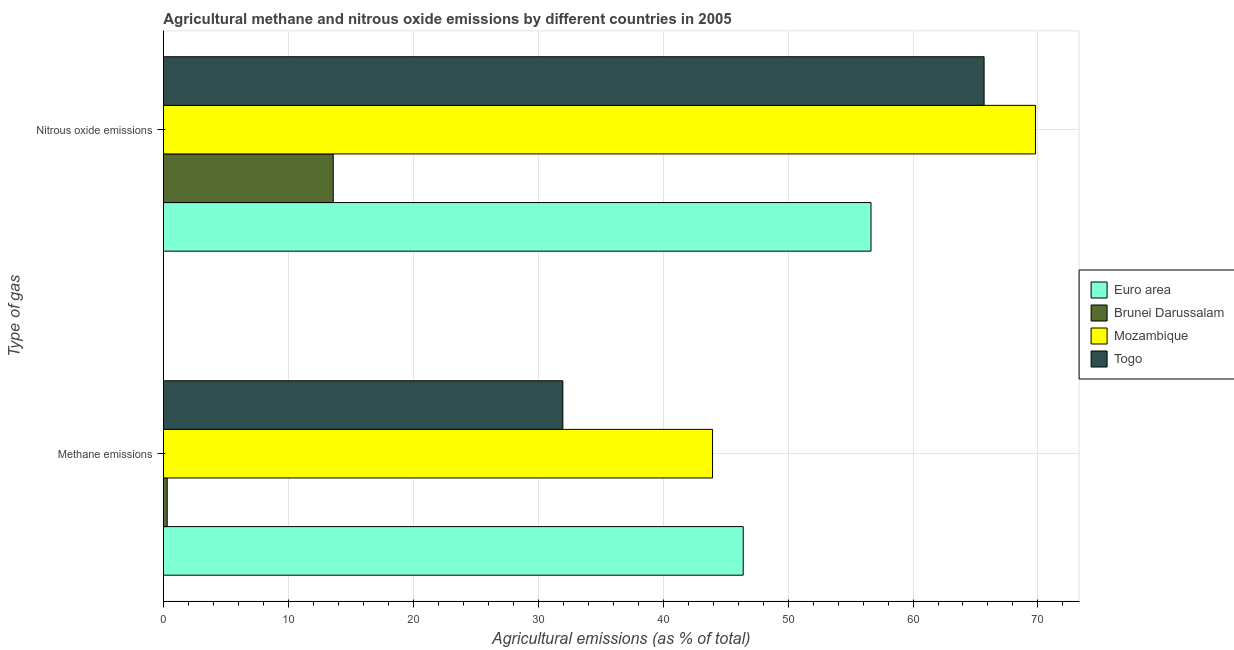How many different coloured bars are there?
Keep it short and to the point. 4. Are the number of bars per tick equal to the number of legend labels?
Give a very brief answer. Yes. Are the number of bars on each tick of the Y-axis equal?
Your answer should be very brief. Yes. How many bars are there on the 2nd tick from the top?
Your answer should be very brief. 4. How many bars are there on the 2nd tick from the bottom?
Ensure brevity in your answer.  4. What is the label of the 2nd group of bars from the top?
Your response must be concise. Methane emissions. What is the amount of nitrous oxide emissions in Euro area?
Offer a very short reply. 56.64. Across all countries, what is the maximum amount of methane emissions?
Provide a succinct answer. 46.41. Across all countries, what is the minimum amount of methane emissions?
Keep it short and to the point. 0.31. In which country was the amount of nitrous oxide emissions minimum?
Give a very brief answer. Brunei Darussalam. What is the total amount of methane emissions in the graph?
Give a very brief answer. 122.65. What is the difference between the amount of nitrous oxide emissions in Togo and that in Mozambique?
Ensure brevity in your answer.  -4.11. What is the difference between the amount of nitrous oxide emissions in Togo and the amount of methane emissions in Brunei Darussalam?
Your response must be concise. 65.38. What is the average amount of methane emissions per country?
Offer a very short reply. 30.66. What is the difference between the amount of methane emissions and amount of nitrous oxide emissions in Brunei Darussalam?
Give a very brief answer. -13.29. What is the ratio of the amount of nitrous oxide emissions in Mozambique to that in Togo?
Make the answer very short. 1.06. Is the amount of nitrous oxide emissions in Euro area less than that in Brunei Darussalam?
Give a very brief answer. No. Are all the bars in the graph horizontal?
Your answer should be compact. Yes. How many countries are there in the graph?
Keep it short and to the point. 4. What is the difference between two consecutive major ticks on the X-axis?
Your response must be concise. 10. How are the legend labels stacked?
Give a very brief answer. Vertical. What is the title of the graph?
Keep it short and to the point. Agricultural methane and nitrous oxide emissions by different countries in 2005. What is the label or title of the X-axis?
Offer a terse response. Agricultural emissions (as % of total). What is the label or title of the Y-axis?
Keep it short and to the point. Type of gas. What is the Agricultural emissions (as % of total) of Euro area in Methane emissions?
Your answer should be very brief. 46.41. What is the Agricultural emissions (as % of total) in Brunei Darussalam in Methane emissions?
Offer a terse response. 0.31. What is the Agricultural emissions (as % of total) in Mozambique in Methane emissions?
Offer a very short reply. 43.96. What is the Agricultural emissions (as % of total) in Togo in Methane emissions?
Your response must be concise. 31.98. What is the Agricultural emissions (as % of total) in Euro area in Nitrous oxide emissions?
Give a very brief answer. 56.64. What is the Agricultural emissions (as % of total) in Brunei Darussalam in Nitrous oxide emissions?
Your answer should be compact. 13.6. What is the Agricultural emissions (as % of total) of Mozambique in Nitrous oxide emissions?
Ensure brevity in your answer.  69.8. What is the Agricultural emissions (as % of total) in Togo in Nitrous oxide emissions?
Your response must be concise. 65.69. Across all Type of gas, what is the maximum Agricultural emissions (as % of total) of Euro area?
Provide a short and direct response. 56.64. Across all Type of gas, what is the maximum Agricultural emissions (as % of total) in Brunei Darussalam?
Ensure brevity in your answer.  13.6. Across all Type of gas, what is the maximum Agricultural emissions (as % of total) of Mozambique?
Make the answer very short. 69.8. Across all Type of gas, what is the maximum Agricultural emissions (as % of total) of Togo?
Provide a succinct answer. 65.69. Across all Type of gas, what is the minimum Agricultural emissions (as % of total) in Euro area?
Offer a terse response. 46.41. Across all Type of gas, what is the minimum Agricultural emissions (as % of total) in Brunei Darussalam?
Keep it short and to the point. 0.31. Across all Type of gas, what is the minimum Agricultural emissions (as % of total) of Mozambique?
Offer a very short reply. 43.96. Across all Type of gas, what is the minimum Agricultural emissions (as % of total) in Togo?
Your answer should be compact. 31.98. What is the total Agricultural emissions (as % of total) in Euro area in the graph?
Your answer should be very brief. 103.05. What is the total Agricultural emissions (as % of total) in Brunei Darussalam in the graph?
Give a very brief answer. 13.91. What is the total Agricultural emissions (as % of total) of Mozambique in the graph?
Make the answer very short. 113.76. What is the total Agricultural emissions (as % of total) in Togo in the graph?
Make the answer very short. 97.67. What is the difference between the Agricultural emissions (as % of total) in Euro area in Methane emissions and that in Nitrous oxide emissions?
Make the answer very short. -10.23. What is the difference between the Agricultural emissions (as % of total) in Brunei Darussalam in Methane emissions and that in Nitrous oxide emissions?
Give a very brief answer. -13.29. What is the difference between the Agricultural emissions (as % of total) in Mozambique in Methane emissions and that in Nitrous oxide emissions?
Keep it short and to the point. -25.84. What is the difference between the Agricultural emissions (as % of total) in Togo in Methane emissions and that in Nitrous oxide emissions?
Your answer should be compact. -33.71. What is the difference between the Agricultural emissions (as % of total) in Euro area in Methane emissions and the Agricultural emissions (as % of total) in Brunei Darussalam in Nitrous oxide emissions?
Ensure brevity in your answer.  32.81. What is the difference between the Agricultural emissions (as % of total) in Euro area in Methane emissions and the Agricultural emissions (as % of total) in Mozambique in Nitrous oxide emissions?
Provide a short and direct response. -23.39. What is the difference between the Agricultural emissions (as % of total) of Euro area in Methane emissions and the Agricultural emissions (as % of total) of Togo in Nitrous oxide emissions?
Keep it short and to the point. -19.28. What is the difference between the Agricultural emissions (as % of total) in Brunei Darussalam in Methane emissions and the Agricultural emissions (as % of total) in Mozambique in Nitrous oxide emissions?
Make the answer very short. -69.49. What is the difference between the Agricultural emissions (as % of total) of Brunei Darussalam in Methane emissions and the Agricultural emissions (as % of total) of Togo in Nitrous oxide emissions?
Give a very brief answer. -65.38. What is the difference between the Agricultural emissions (as % of total) of Mozambique in Methane emissions and the Agricultural emissions (as % of total) of Togo in Nitrous oxide emissions?
Offer a terse response. -21.73. What is the average Agricultural emissions (as % of total) in Euro area per Type of gas?
Ensure brevity in your answer.  51.52. What is the average Agricultural emissions (as % of total) of Brunei Darussalam per Type of gas?
Provide a short and direct response. 6.95. What is the average Agricultural emissions (as % of total) of Mozambique per Type of gas?
Ensure brevity in your answer.  56.88. What is the average Agricultural emissions (as % of total) in Togo per Type of gas?
Offer a terse response. 48.83. What is the difference between the Agricultural emissions (as % of total) in Euro area and Agricultural emissions (as % of total) in Brunei Darussalam in Methane emissions?
Your response must be concise. 46.1. What is the difference between the Agricultural emissions (as % of total) of Euro area and Agricultural emissions (as % of total) of Mozambique in Methane emissions?
Your answer should be very brief. 2.45. What is the difference between the Agricultural emissions (as % of total) in Euro area and Agricultural emissions (as % of total) in Togo in Methane emissions?
Offer a terse response. 14.44. What is the difference between the Agricultural emissions (as % of total) in Brunei Darussalam and Agricultural emissions (as % of total) in Mozambique in Methane emissions?
Offer a terse response. -43.65. What is the difference between the Agricultural emissions (as % of total) in Brunei Darussalam and Agricultural emissions (as % of total) in Togo in Methane emissions?
Provide a short and direct response. -31.67. What is the difference between the Agricultural emissions (as % of total) of Mozambique and Agricultural emissions (as % of total) of Togo in Methane emissions?
Offer a very short reply. 11.98. What is the difference between the Agricultural emissions (as % of total) in Euro area and Agricultural emissions (as % of total) in Brunei Darussalam in Nitrous oxide emissions?
Offer a terse response. 43.04. What is the difference between the Agricultural emissions (as % of total) in Euro area and Agricultural emissions (as % of total) in Mozambique in Nitrous oxide emissions?
Ensure brevity in your answer.  -13.16. What is the difference between the Agricultural emissions (as % of total) of Euro area and Agricultural emissions (as % of total) of Togo in Nitrous oxide emissions?
Your answer should be very brief. -9.05. What is the difference between the Agricultural emissions (as % of total) of Brunei Darussalam and Agricultural emissions (as % of total) of Mozambique in Nitrous oxide emissions?
Your answer should be very brief. -56.2. What is the difference between the Agricultural emissions (as % of total) in Brunei Darussalam and Agricultural emissions (as % of total) in Togo in Nitrous oxide emissions?
Provide a short and direct response. -52.09. What is the difference between the Agricultural emissions (as % of total) in Mozambique and Agricultural emissions (as % of total) in Togo in Nitrous oxide emissions?
Offer a terse response. 4.11. What is the ratio of the Agricultural emissions (as % of total) of Euro area in Methane emissions to that in Nitrous oxide emissions?
Your answer should be very brief. 0.82. What is the ratio of the Agricultural emissions (as % of total) of Brunei Darussalam in Methane emissions to that in Nitrous oxide emissions?
Ensure brevity in your answer.  0.02. What is the ratio of the Agricultural emissions (as % of total) in Mozambique in Methane emissions to that in Nitrous oxide emissions?
Ensure brevity in your answer.  0.63. What is the ratio of the Agricultural emissions (as % of total) of Togo in Methane emissions to that in Nitrous oxide emissions?
Your response must be concise. 0.49. What is the difference between the highest and the second highest Agricultural emissions (as % of total) of Euro area?
Ensure brevity in your answer.  10.23. What is the difference between the highest and the second highest Agricultural emissions (as % of total) of Brunei Darussalam?
Provide a short and direct response. 13.29. What is the difference between the highest and the second highest Agricultural emissions (as % of total) in Mozambique?
Make the answer very short. 25.84. What is the difference between the highest and the second highest Agricultural emissions (as % of total) in Togo?
Provide a short and direct response. 33.71. What is the difference between the highest and the lowest Agricultural emissions (as % of total) in Euro area?
Offer a terse response. 10.23. What is the difference between the highest and the lowest Agricultural emissions (as % of total) in Brunei Darussalam?
Give a very brief answer. 13.29. What is the difference between the highest and the lowest Agricultural emissions (as % of total) of Mozambique?
Your response must be concise. 25.84. What is the difference between the highest and the lowest Agricultural emissions (as % of total) of Togo?
Your answer should be compact. 33.71. 